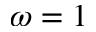<formula> <loc_0><loc_0><loc_500><loc_500>\omega = 1</formula> 